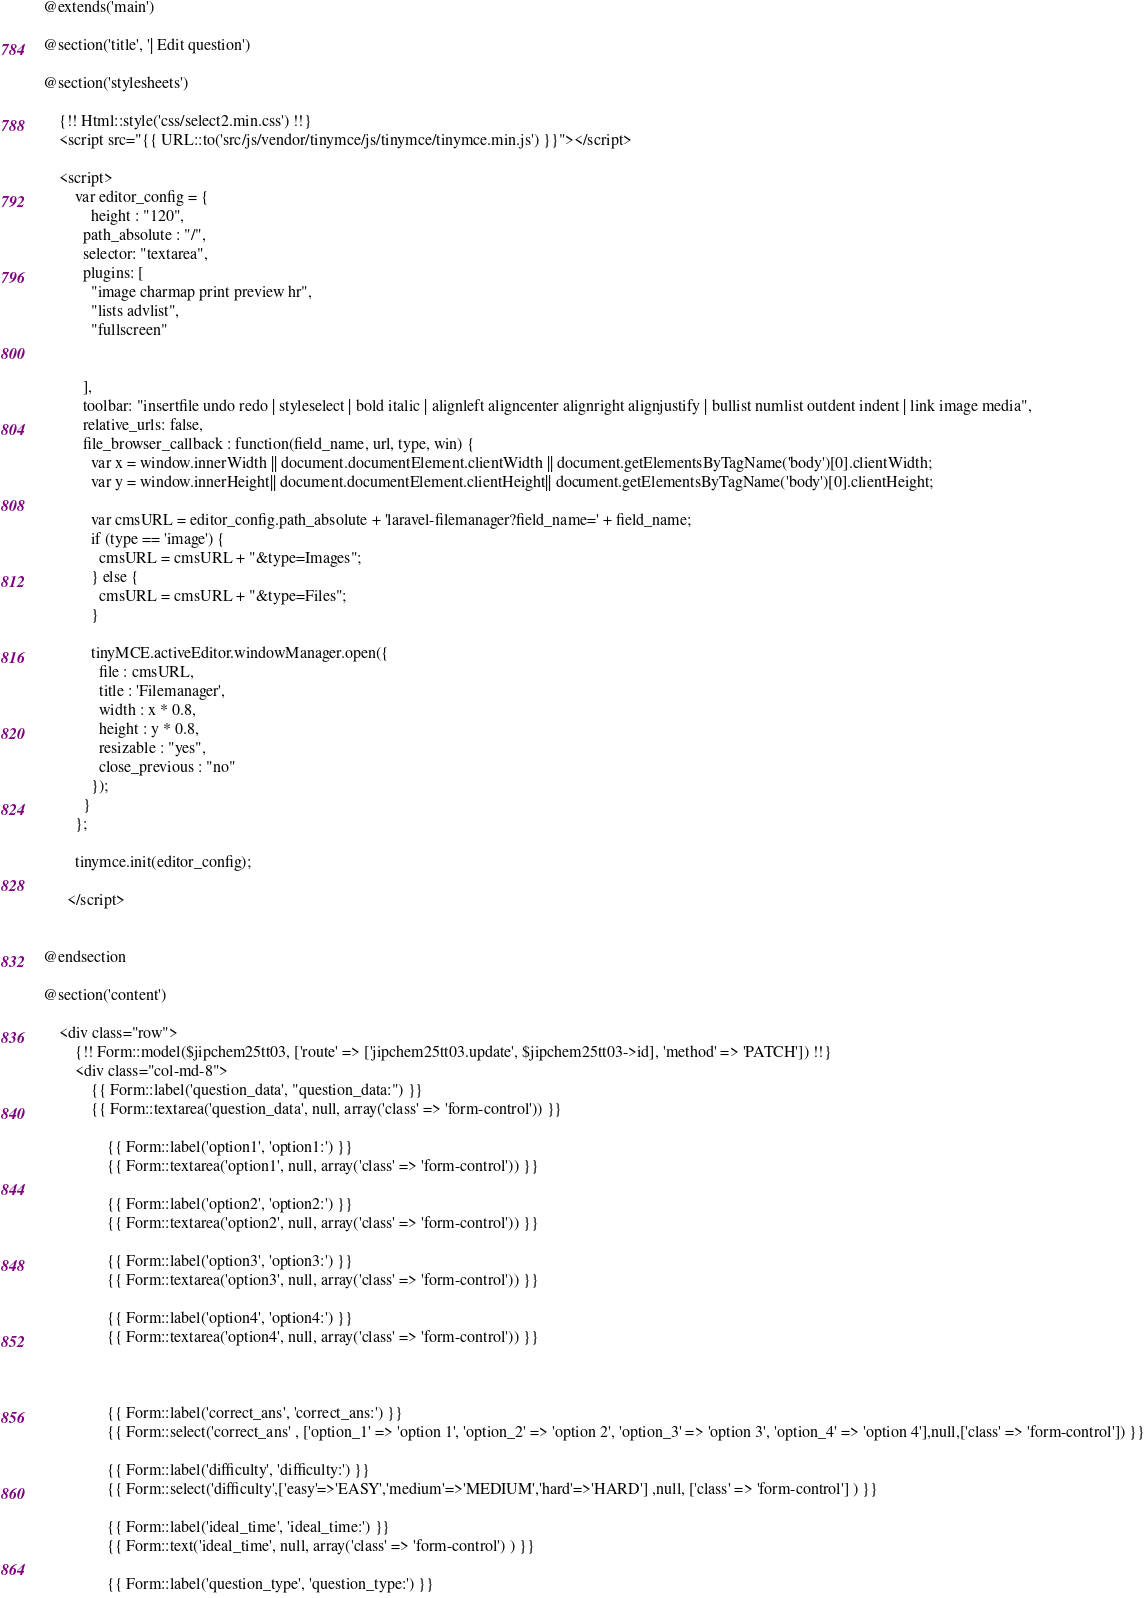<code> <loc_0><loc_0><loc_500><loc_500><_PHP_>@extends('main')

@section('title', '| Edit question')

@section('stylesheets')

    {!! Html::style('css/select2.min.css') !!}
    <script src="{{ URL::to('src/js/vendor/tinymce/js/tinymce/tinymce.min.js') }}"></script>

    <script>
        var editor_config = {
            height : "120",
          path_absolute : "/",
          selector: "textarea",
          plugins: [
            "image charmap print preview hr",
            "lists advlist",
            "fullscreen"


          ],
          toolbar: "insertfile undo redo | styleselect | bold italic | alignleft aligncenter alignright alignjustify | bullist numlist outdent indent | link image media",
          relative_urls: false,
          file_browser_callback : function(field_name, url, type, win) {
            var x = window.innerWidth || document.documentElement.clientWidth || document.getElementsByTagName('body')[0].clientWidth;
            var y = window.innerHeight|| document.documentElement.clientHeight|| document.getElementsByTagName('body')[0].clientHeight;

            var cmsURL = editor_config.path_absolute + 'laravel-filemanager?field_name=' + field_name;
            if (type == 'image') {
              cmsURL = cmsURL + "&type=Images";
            } else {
              cmsURL = cmsURL + "&type=Files";
            }

            tinyMCE.activeEditor.windowManager.open({
              file : cmsURL,
              title : 'Filemanager',
              width : x * 0.8,
              height : y * 0.8,
              resizable : "yes",
              close_previous : "no"
            });
          }
        };

        tinymce.init(editor_config);

      </script>


@endsection

@section('content')

	<div class="row">
		{!! Form::model($jipchem25tt03, ['route' => ['jipchem25tt03.update', $jipchem25tt03->id], 'method' => 'PATCH']) !!}
		<div class="col-md-8">
            {{ Form::label('question_data', "question_data:") }}
			{{ Form::textarea('question_data', null, array('class' => 'form-control')) }}

				{{ Form::label('option1', 'option1:') }}
				{{ Form::textarea('option1', null, array('class' => 'form-control')) }}

				{{ Form::label('option2', 'option2:') }}
				{{ Form::textarea('option2', null, array('class' => 'form-control')) }}

				{{ Form::label('option3', 'option3:') }}
				{{ Form::textarea('option3', null, array('class' => 'form-control')) }}

				{{ Form::label('option4', 'option4:') }}
                {{ Form::textarea('option4', null, array('class' => 'form-control')) }}



				{{ Form::label('correct_ans', 'correct_ans:') }}
				{{ Form::select('correct_ans' , ['option_1' => 'option 1', 'option_2' => 'option 2', 'option_3' => 'option 3', 'option_4' => 'option 4'],null,['class' => 'form-control']) }}

				{{ Form::label('difficulty', 'difficulty:') }}
				{{ Form::select('difficulty',['easy'=>'EASY','medium'=>'MEDIUM','hard'=>'HARD'] ,null, ['class' => 'form-control'] ) }}

				{{ Form::label('ideal_time', 'ideal_time:') }}
				{{ Form::text('ideal_time', null, array('class' => 'form-control') ) }}

				{{ Form::label('question_type', 'question_type:') }}</code> 